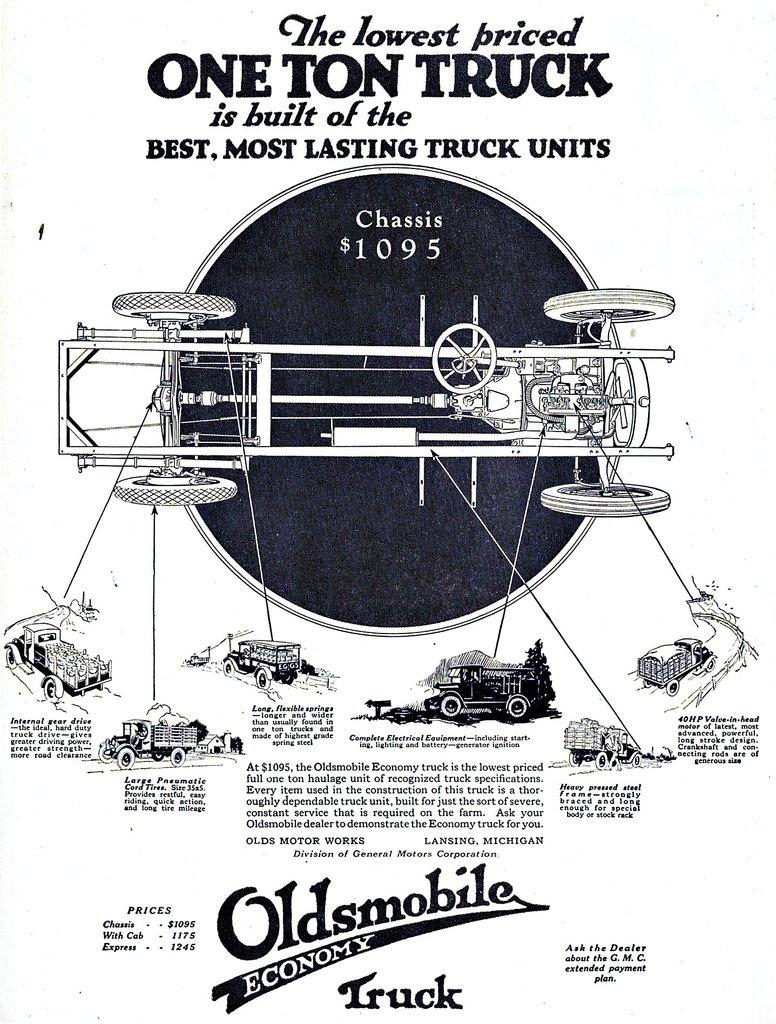What type of objects can be seen in the image? There are truck parts in the image. Is there any text or writing in the image? Yes, there is a paper with text in the image. What color is the background of the image? The background of the image appears to be white. How does the guide help the person sleep in the image? There is no guide or person sleeping in the image; it only features truck parts and a paper with text. 